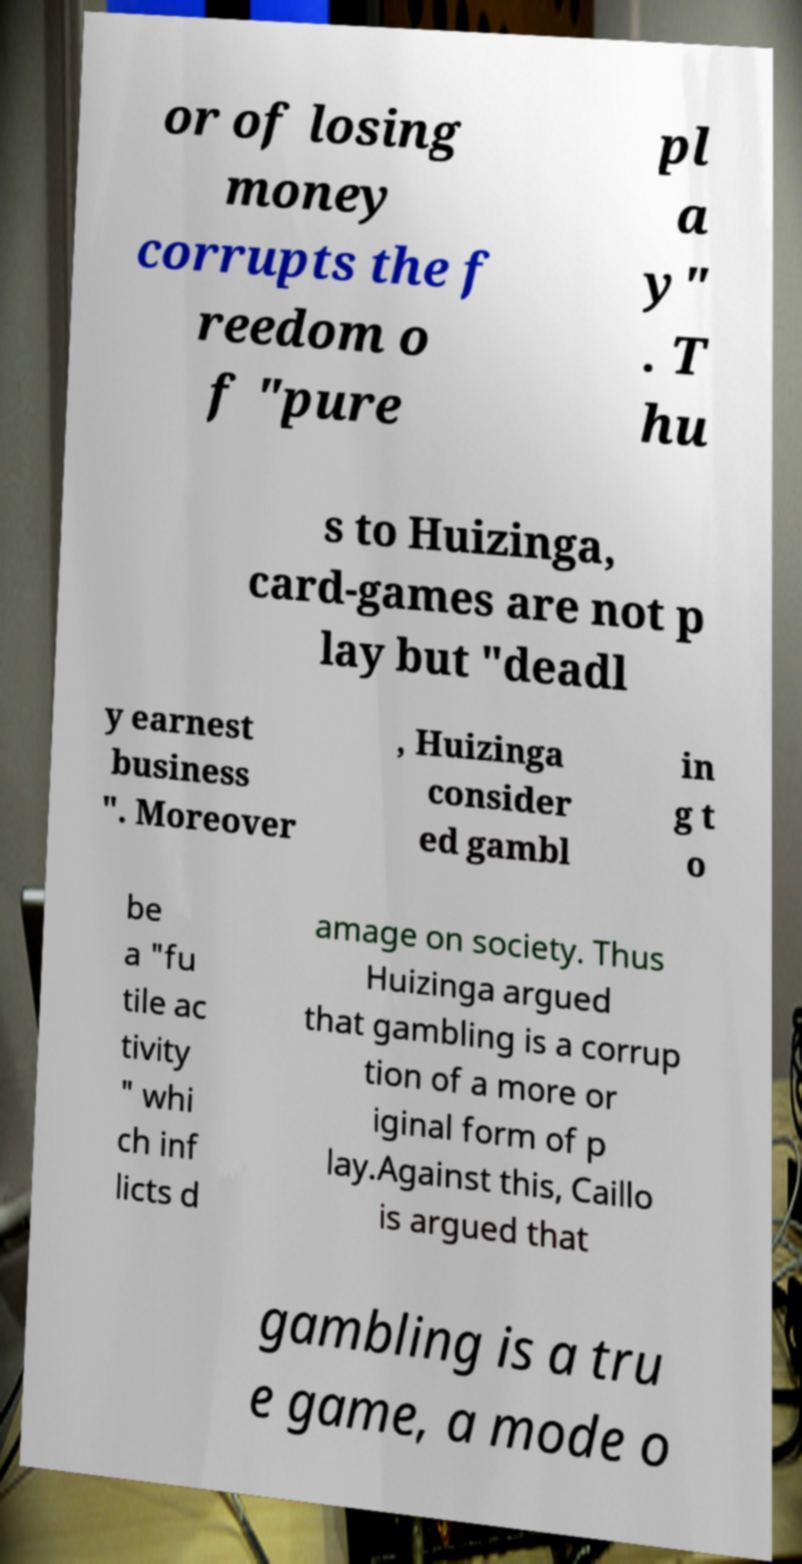Could you assist in decoding the text presented in this image and type it out clearly? or of losing money corrupts the f reedom o f "pure pl a y" . T hu s to Huizinga, card-games are not p lay but "deadl y earnest business ". Moreover , Huizinga consider ed gambl in g t o be a "fu tile ac tivity " whi ch inf licts d amage on society. Thus Huizinga argued that gambling is a corrup tion of a more or iginal form of p lay.Against this, Caillo is argued that gambling is a tru e game, a mode o 